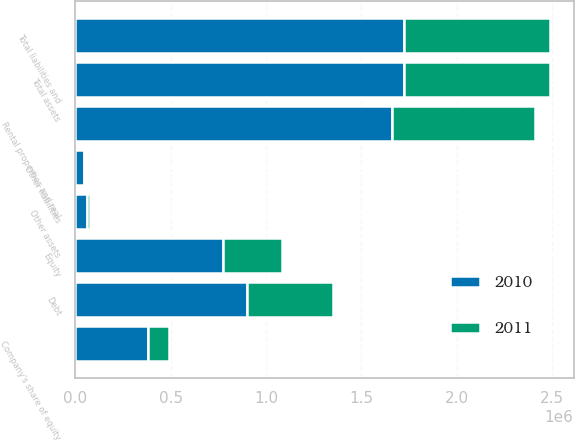Convert chart. <chart><loc_0><loc_0><loc_500><loc_500><stacked_bar_chart><ecel><fcel>Rental properties and real<fcel>Other assets<fcel>Total assets<fcel>Debt<fcel>Other liabilities<fcel>Equity<fcel>Total liabilities and<fcel>Company's share of equity<nl><fcel>2010<fcel>1.65908e+06<fcel>63847<fcel>1.72292e+06<fcel>900095<fcel>48518<fcel>774312<fcel>1.72292e+06<fcel>383412<nl><fcel>2011<fcel>750808<fcel>15864<fcel>766672<fcel>450693<fcel>7076<fcel>308903<fcel>766672<fcel>107201<nl></chart> 